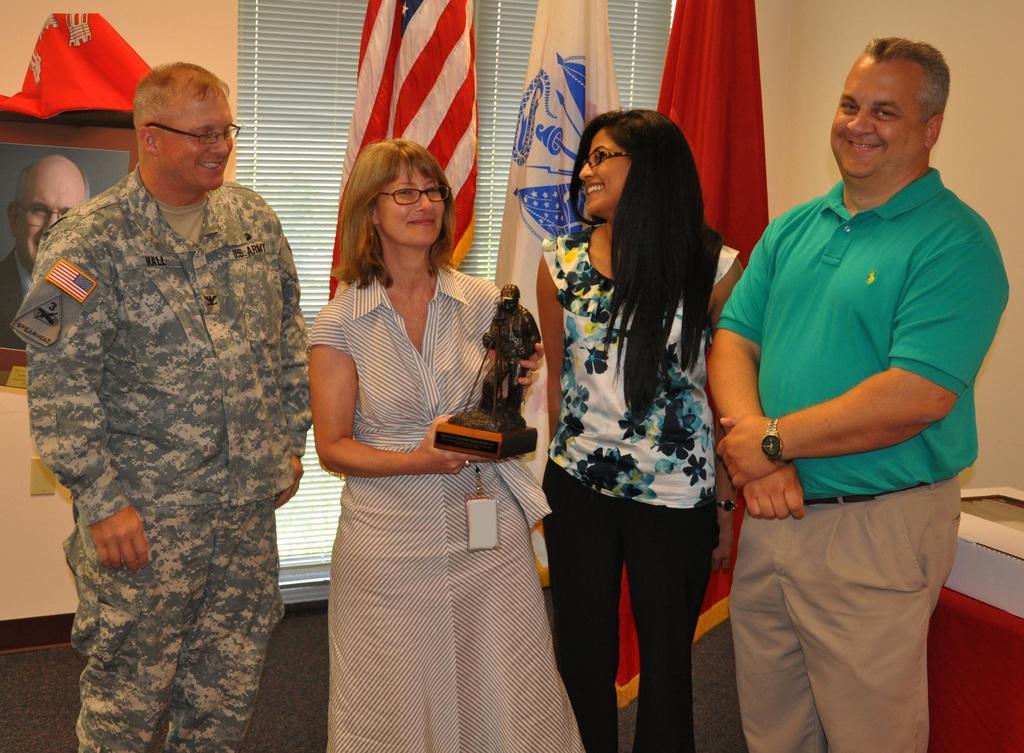Can you describe this image briefly? In this picture I can see there some people standing and the person here on to left is holding a statue and in the backdrop there are flags and there is a wall. 